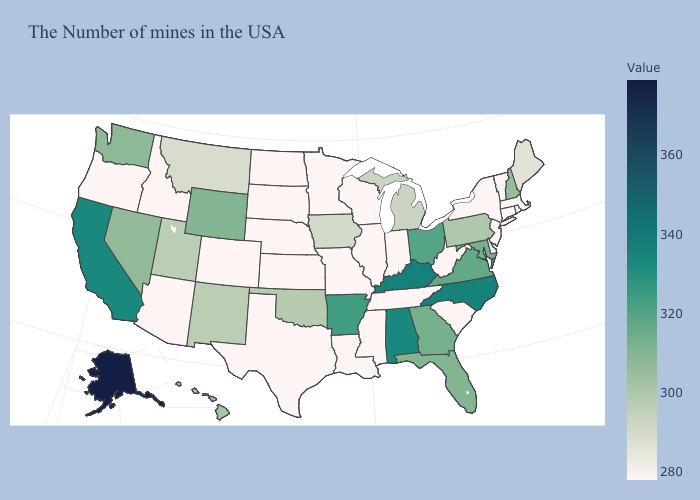Among the states that border Illinois , does Iowa have the highest value?
Keep it brief. No. Which states hav the highest value in the South?
Short answer required. Kentucky. Among the states that border Tennessee , does Mississippi have the lowest value?
Be succinct. Yes. Which states have the highest value in the USA?
Be succinct. Alaska. Which states have the highest value in the USA?
Answer briefly. Alaska. Which states have the lowest value in the USA?
Concise answer only. Massachusetts, Rhode Island, Vermont, Connecticut, New York, New Jersey, South Carolina, West Virginia, Indiana, Tennessee, Wisconsin, Illinois, Mississippi, Louisiana, Missouri, Minnesota, Kansas, Nebraska, Texas, South Dakota, North Dakota, Colorado, Arizona, Idaho, Oregon. 